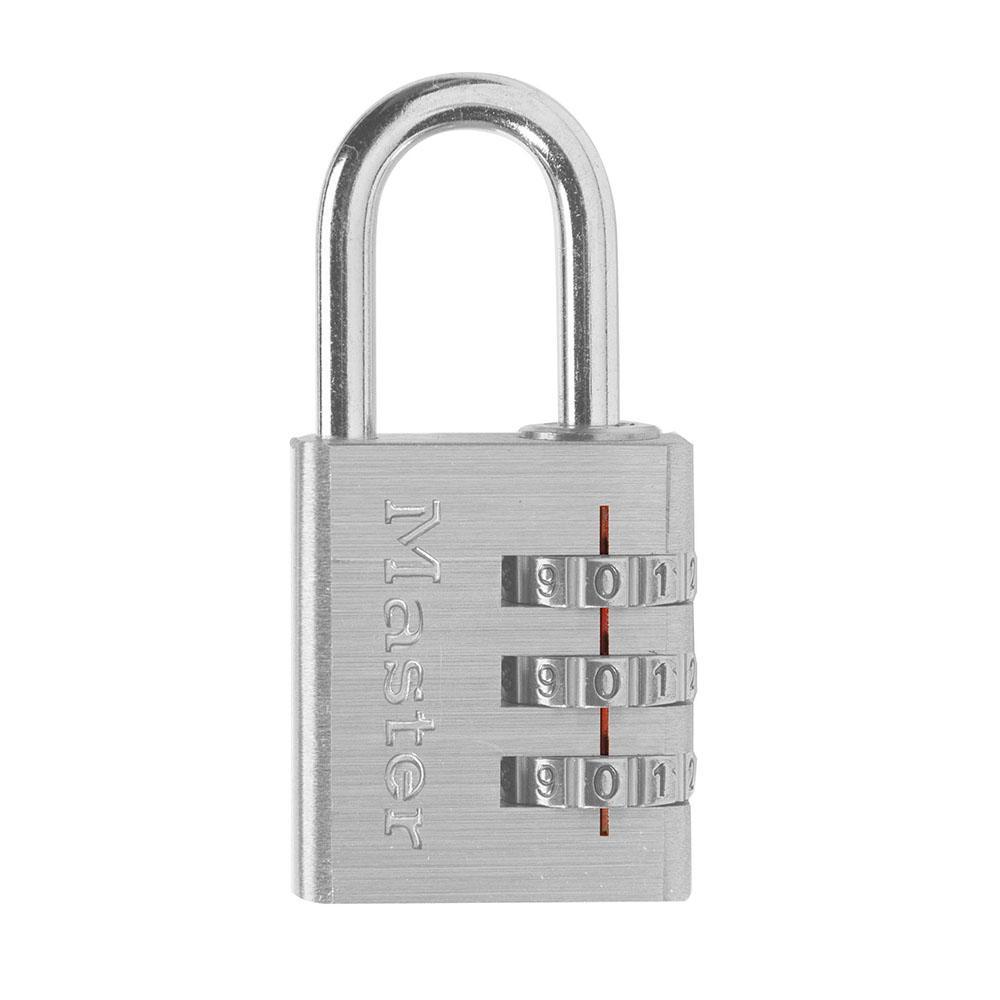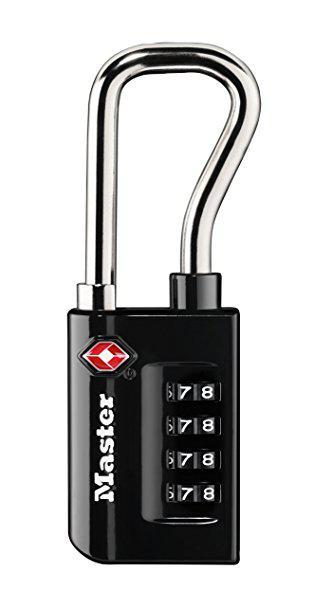The first image is the image on the left, the second image is the image on the right. Analyze the images presented: Is the assertion "All locks have a loop on the top and exactly three rows of number belts on the front of the lock." valid? Answer yes or no. No. The first image is the image on the left, the second image is the image on the right. Evaluate the accuracy of this statement regarding the images: "An image features exactly one combination lock, which is black.". Is it true? Answer yes or no. Yes. 